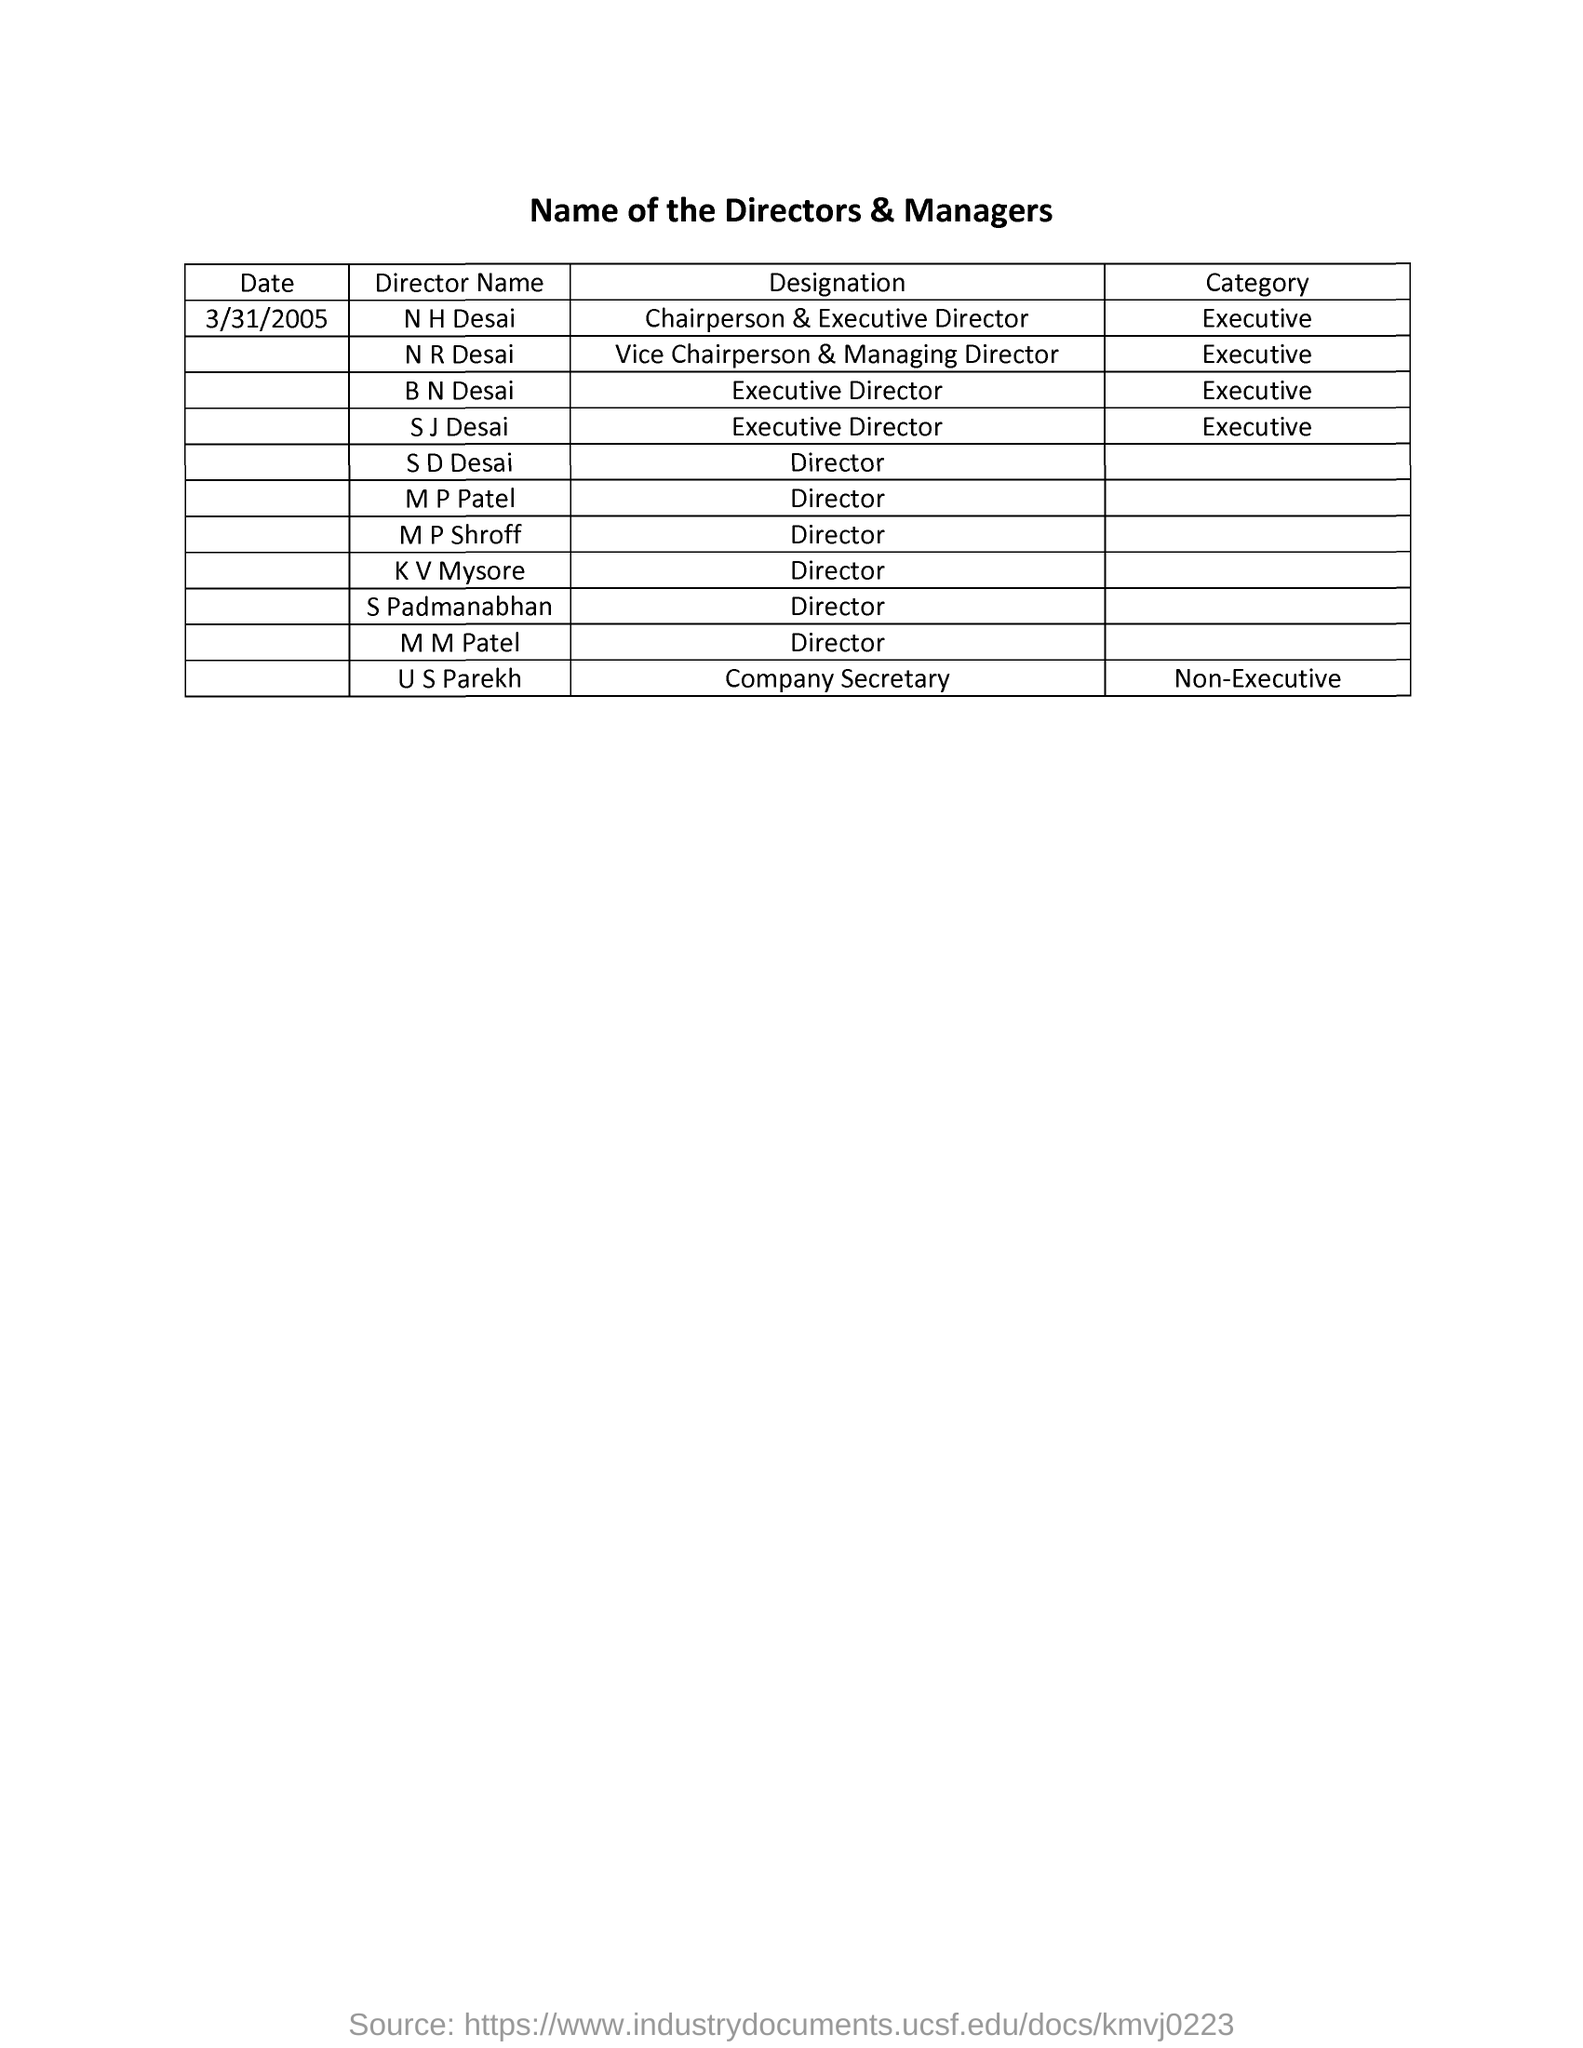Indicate a few pertinent items in this graphic. U S Parekh is a company secretary with a designation. N H Desai holds the designation of chairperson and executive director. S D Desai is a director. U S Parekh is a non-executive individual. N. R. Desai is an executive. 